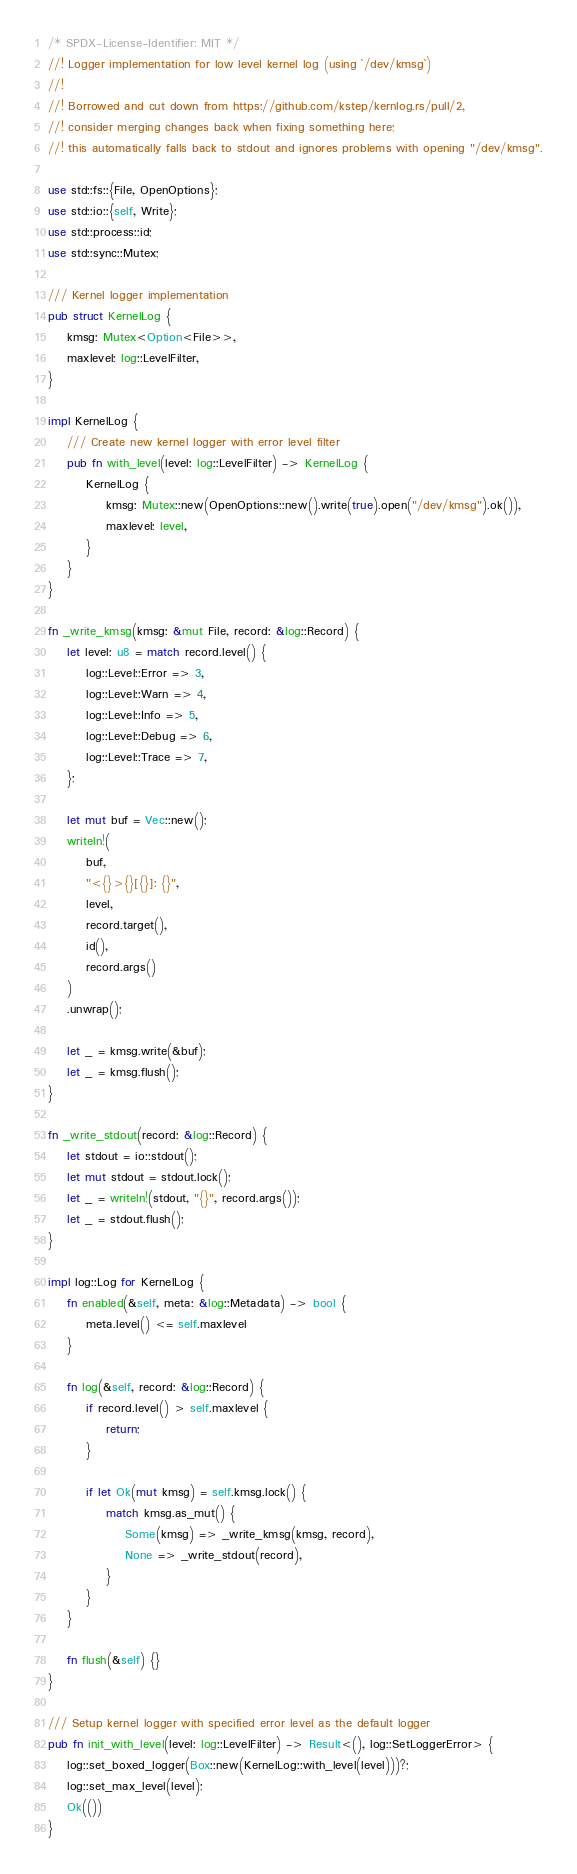Convert code to text. <code><loc_0><loc_0><loc_500><loc_500><_Rust_>/* SPDX-License-Identifier: MIT */
//! Logger implementation for low level kernel log (using `/dev/kmsg`)
//!
//! Borrowed and cut down from https://github.com/kstep/kernlog.rs/pull/2,
//! consider merging changes back when fixing something here;
//! this automatically falls back to stdout and ignores problems with opening "/dev/kmsg".

use std::fs::{File, OpenOptions};
use std::io::{self, Write};
use std::process::id;
use std::sync::Mutex;

/// Kernel logger implementation
pub struct KernelLog {
    kmsg: Mutex<Option<File>>,
    maxlevel: log::LevelFilter,
}

impl KernelLog {
    /// Create new kernel logger with error level filter
    pub fn with_level(level: log::LevelFilter) -> KernelLog {
        KernelLog {
            kmsg: Mutex::new(OpenOptions::new().write(true).open("/dev/kmsg").ok()),
            maxlevel: level,
        }
    }
}

fn _write_kmsg(kmsg: &mut File, record: &log::Record) {
    let level: u8 = match record.level() {
        log::Level::Error => 3,
        log::Level::Warn => 4,
        log::Level::Info => 5,
        log::Level::Debug => 6,
        log::Level::Trace => 7,
    };

    let mut buf = Vec::new();
    writeln!(
        buf,
        "<{}>{}[{}]: {}",
        level,
        record.target(),
        id(),
        record.args()
    )
    .unwrap();

    let _ = kmsg.write(&buf);
    let _ = kmsg.flush();
}

fn _write_stdout(record: &log::Record) {
    let stdout = io::stdout();
    let mut stdout = stdout.lock();
    let _ = writeln!(stdout, "{}", record.args());
    let _ = stdout.flush();
}

impl log::Log for KernelLog {
    fn enabled(&self, meta: &log::Metadata) -> bool {
        meta.level() <= self.maxlevel
    }

    fn log(&self, record: &log::Record) {
        if record.level() > self.maxlevel {
            return;
        }

        if let Ok(mut kmsg) = self.kmsg.lock() {
            match kmsg.as_mut() {
                Some(kmsg) => _write_kmsg(kmsg, record),
                None => _write_stdout(record),
            }
        }
    }

    fn flush(&self) {}
}

/// Setup kernel logger with specified error level as the default logger
pub fn init_with_level(level: log::LevelFilter) -> Result<(), log::SetLoggerError> {
    log::set_boxed_logger(Box::new(KernelLog::with_level(level)))?;
    log::set_max_level(level);
    Ok(())
}
</code> 